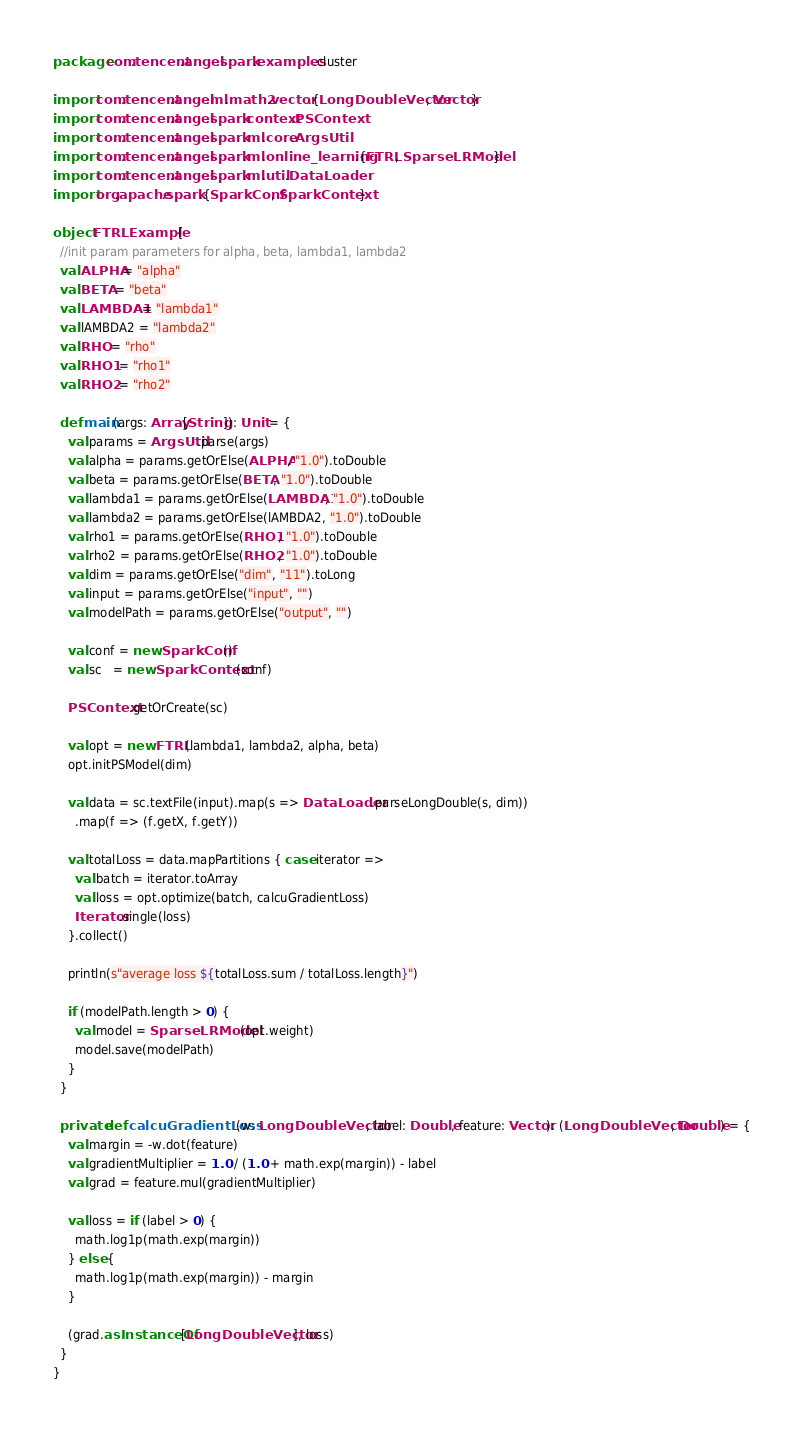Convert code to text. <code><loc_0><loc_0><loc_500><loc_500><_Scala_>package com.tencent.angel.spark.examples.cluster

import com.tencent.angel.ml.math2.vector.{LongDoubleVector, Vector}
import com.tencent.angel.spark.context.PSContext
import com.tencent.angel.spark.ml.core.ArgsUtil
import com.tencent.angel.spark.ml.online_learning.{FTRL, SparseLRModel}
import com.tencent.angel.spark.ml.util.DataLoader
import org.apache.spark.{SparkConf, SparkContext}

object FTRLExample {
  //init param parameters for alpha, beta, lambda1, lambda2
  val ALPHA = "alpha"
  val BETA = "beta"
  val LAMBDA1 = "lambda1"
  val lAMBDA2 = "lambda2"
  val RHO = "rho"
  val RHO1 = "rho1"
  val RHO2 = "rho2"

  def main(args: Array[String]): Unit = {
    val params = ArgsUtil.parse(args)
    val alpha = params.getOrElse(ALPHA, "1.0").toDouble
    val beta = params.getOrElse(BETA, "1.0").toDouble
    val lambda1 = params.getOrElse(LAMBDA1, "1.0").toDouble
    val lambda2 = params.getOrElse(lAMBDA2, "1.0").toDouble
    val rho1 = params.getOrElse(RHO1, "1.0").toDouble
    val rho2 = params.getOrElse(RHO2, "1.0").toDouble
    val dim = params.getOrElse("dim", "11").toLong
    val input = params.getOrElse("input", "")
    val modelPath = params.getOrElse("output", "")

    val conf = new SparkConf()
    val sc   = new SparkContext(conf)

    PSContext.getOrCreate(sc)

    val opt = new FTRL(lambda1, lambda2, alpha, beta)
    opt.initPSModel(dim)

    val data = sc.textFile(input).map(s => DataLoader.parseLongDouble(s, dim))
      .map(f => (f.getX, f.getY))

    val totalLoss = data.mapPartitions { case iterator =>
      val batch = iterator.toArray
      val loss = opt.optimize(batch, calcuGradientLoss)
      Iterator.single(loss)
    }.collect()

    println(s"average loss ${totalLoss.sum / totalLoss.length}")

    if (modelPath.length > 0) {
      val model = SparseLRModel(opt.weight)
      model.save(modelPath)
    }
  }

  private def calcuGradientLoss(w: LongDoubleVector, label: Double, feature: Vector): (LongDoubleVector, Double) = {
    val margin = -w.dot(feature)
    val gradientMultiplier = 1.0 / (1.0 + math.exp(margin)) - label
    val grad = feature.mul(gradientMultiplier)

    val loss = if (label > 0) {
      math.log1p(math.exp(margin))
    } else {
      math.log1p(math.exp(margin)) - margin
    }

    (grad.asInstanceOf[LongDoubleVector], loss)
  }
}
</code> 